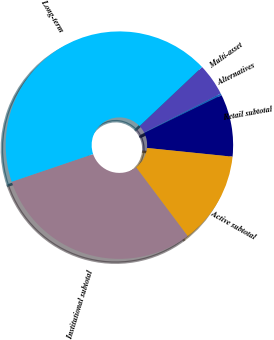Convert chart to OTSL. <chart><loc_0><loc_0><loc_500><loc_500><pie_chart><fcel>Multi-asset<fcel>Alternatives<fcel>Retail subtotal<fcel>Active subtotal<fcel>Institutional subtotal<fcel>Long-term<nl><fcel>4.56%<fcel>0.27%<fcel>8.85%<fcel>13.14%<fcel>30.03%<fcel>43.16%<nl></chart> 